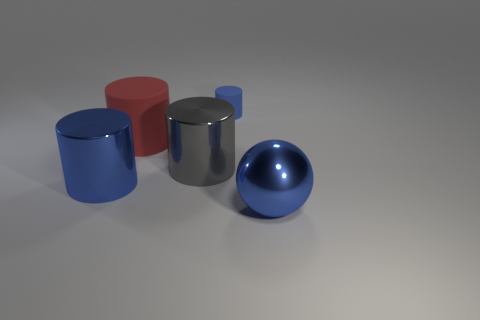What can you infer about the material of the objects shown? From their appearance, the ball and one cylinder exhibit shiny surfaces, suggesting they may be made of a metallic material. The other two cylinders have matte finishes, which could imply a plastic or painted surface. How can you distinguish between metallic and matte finishes? Metallic finishes reflect light in a sharper, clearer way, often with highlights and defined reflections, whereas matte finishes scatter light, resulting in a more even and less reflective surface. 